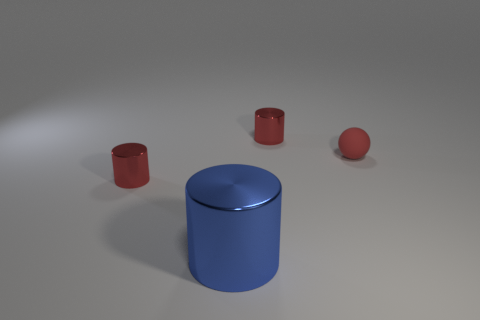Is there a cyan cylinder that has the same size as the red rubber ball?
Your answer should be very brief. No. How many objects are small red objects that are behind the rubber thing or tiny cylinders behind the rubber object?
Make the answer very short. 1. Are there any blue rubber objects of the same shape as the big blue metal object?
Provide a short and direct response. No. Is the number of red matte things less than the number of cylinders?
Offer a terse response. Yes. There is a metal cylinder that is to the left of the big blue shiny thing; is it the same size as the blue cylinder to the left of the small matte thing?
Provide a succinct answer. No. What number of objects are big blue cylinders or tiny cylinders?
Offer a very short reply. 3. How big is the red metal thing that is behind the red matte ball?
Offer a very short reply. Small. There is a red metal cylinder that is behind the small red ball behind the big blue cylinder; what number of blue metal objects are behind it?
Keep it short and to the point. 0. What number of red cylinders are both in front of the tiny ball and behind the ball?
Keep it short and to the point. 0. What shape is the small red metallic object behind the tiny red rubber object?
Keep it short and to the point. Cylinder. 